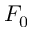<formula> <loc_0><loc_0><loc_500><loc_500>F _ { 0 }</formula> 